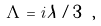<formula> <loc_0><loc_0><loc_500><loc_500>\Lambda = i \lambda / 3 \ ,</formula> 